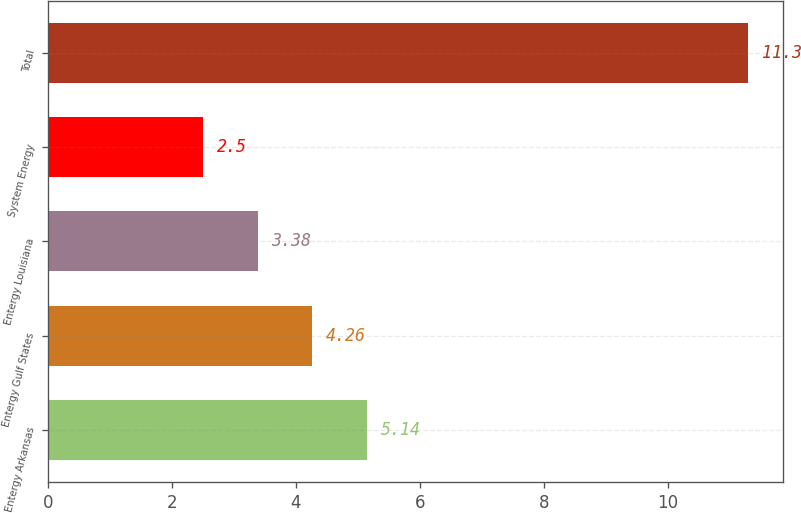Convert chart to OTSL. <chart><loc_0><loc_0><loc_500><loc_500><bar_chart><fcel>Entergy Arkansas<fcel>Entergy Gulf States<fcel>Entergy Louisiana<fcel>System Energy<fcel>Total<nl><fcel>5.14<fcel>4.26<fcel>3.38<fcel>2.5<fcel>11.3<nl></chart> 